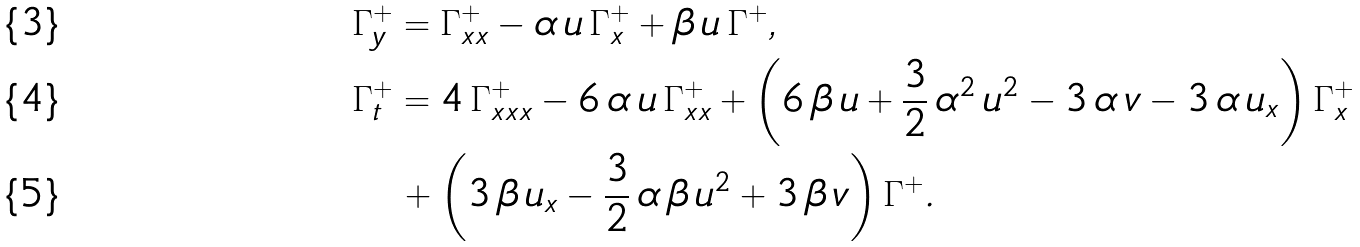Convert formula to latex. <formula><loc_0><loc_0><loc_500><loc_500>& \Gamma _ { y } ^ { + } = \Gamma _ { x x } ^ { + } - \alpha \, u \, \Gamma _ { x } ^ { + } + \beta \, u \, \Gamma ^ { + } , \\ & \Gamma _ { t } ^ { + } = 4 \, \Gamma _ { x x x } ^ { + } - 6 \, \alpha \, u \, \Gamma _ { x x } ^ { + } + \left ( 6 \, \beta \, u + \frac { 3 } { 2 } \, \alpha ^ { 2 } \, u ^ { 2 } - 3 \, \alpha \, v - 3 \, \alpha \, u _ { x } \right ) \Gamma _ { x } ^ { + } \\ & \quad + \left ( 3 \, \beta \, u _ { x } - \frac { 3 } { 2 } \, \alpha \, \beta \, u ^ { 2 } + 3 \, \beta \, v \right ) \Gamma ^ { + } .</formula> 